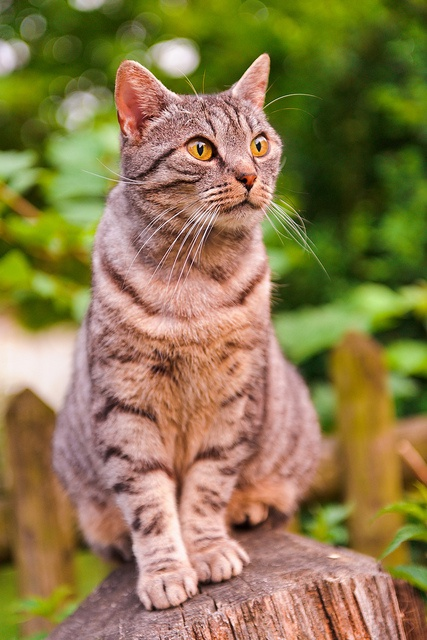Describe the objects in this image and their specific colors. I can see a cat in gray, lightpink, brown, darkgray, and salmon tones in this image. 